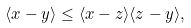<formula> <loc_0><loc_0><loc_500><loc_500>\langle x - y \rangle \leq \langle x - z \rangle \langle z - y \rangle ,</formula> 